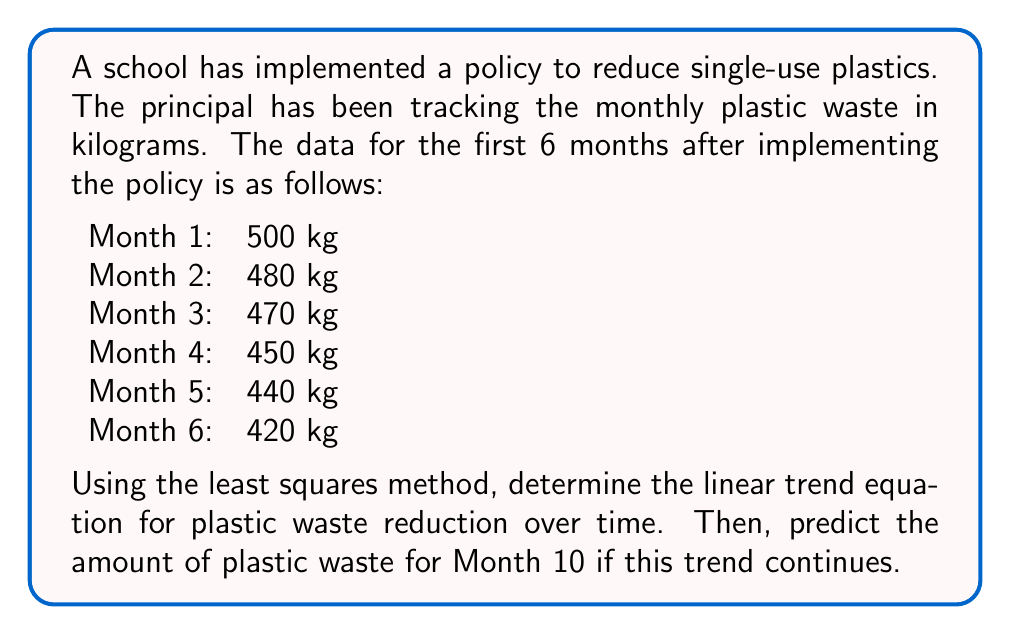Can you solve this math problem? To find the linear trend equation using the least squares method, we need to calculate the slope (b) and y-intercept (a) of the line $y = a + bx$, where x represents the month and y represents the plastic waste in kg.

Step 1: Calculate the means of x and y
$\bar{x} = \frac{1 + 2 + 3 + 4 + 5 + 6}{6} = 3.5$
$\bar{y} = \frac{500 + 480 + 470 + 450 + 440 + 420}{6} = 460$

Step 2: Calculate the slope (b)
$$b = \frac{\sum(x - \bar{x})(y - \bar{y})}{\sum(x - \bar{x})^2}$$

Create a table to calculate the numerator and denominator:

| x | y | x - $\bar{x}$ | y - $\bar{y}$ | (x - $\bar{x}$)(y - $\bar{y}$) | (x - $\bar{x}$)² |
|---|---|---------------|---------------|--------------------------------|-------------------|
| 1 | 500 | -2.5 | 40 | -100 | 6.25 |
| 2 | 480 | -1.5 | 20 | -30 | 2.25 |
| 3 | 470 | -0.5 | 10 | -5 | 0.25 |
| 4 | 450 | 0.5 | -10 | -5 | 0.25 |
| 5 | 440 | 1.5 | -20 | -30 | 2.25 |
| 6 | 420 | 2.5 | -40 | -100 | 6.25 |
| Sum | | | | -270 | 17.5 |

$$b = \frac{-270}{17.5} = -15.43$$

Step 3: Calculate the y-intercept (a)
$a = \bar{y} - b\bar{x} = 460 - (-15.43 \times 3.5) = 514.01$

Step 4: Write the linear trend equation
$y = 514.01 - 15.43x$

Step 5: Predict the plastic waste for Month 10
$y = 514.01 - 15.43(10) = 359.71$ kg
Answer: The linear trend equation is $y = 514.01 - 15.43x$, where x is the month number and y is the predicted plastic waste in kg. The predicted plastic waste for Month 10 is approximately 359.71 kg. 